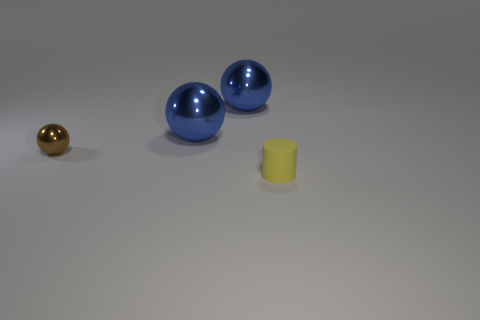Subtract all brown metal balls. How many balls are left? 2 Subtract all blue spheres. How many spheres are left? 1 Add 2 yellow cylinders. How many objects exist? 6 Subtract 2 balls. How many balls are left? 1 Subtract all spheres. How many objects are left? 1 Subtract all brown cylinders. How many brown balls are left? 1 Subtract all large blue metallic spheres. Subtract all matte cylinders. How many objects are left? 1 Add 4 tiny metallic balls. How many tiny metallic balls are left? 5 Add 4 small matte cylinders. How many small matte cylinders exist? 5 Subtract 0 cyan balls. How many objects are left? 4 